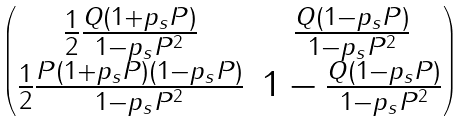<formula> <loc_0><loc_0><loc_500><loc_500>\begin{pmatrix} \frac { 1 } { 2 } \frac { Q ( 1 + p _ { s } P ) } { 1 - p _ { s } P ^ { 2 } } & \frac { Q ( 1 - p _ { s } P ) } { 1 - p _ { s } P ^ { 2 } } \\ \frac { 1 } { 2 } \frac { P ( 1 + p _ { s } P ) ( 1 - p _ { s } P ) } { 1 - p _ { s } P ^ { 2 } } & 1 - \frac { Q ( 1 - p _ { s } P ) } { 1 - p _ { s } P ^ { 2 } } \end{pmatrix}</formula> 